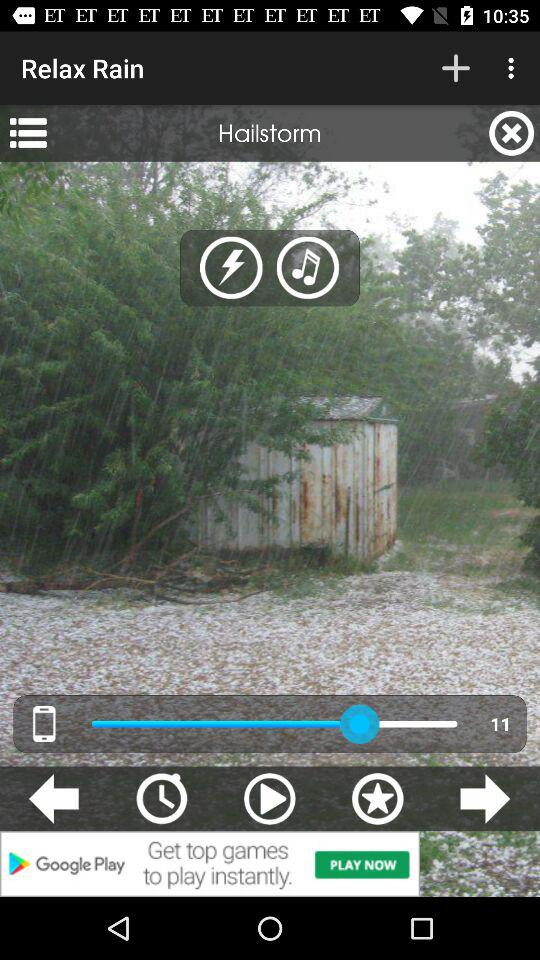What is the application name? The application name is "Relax Rain". 